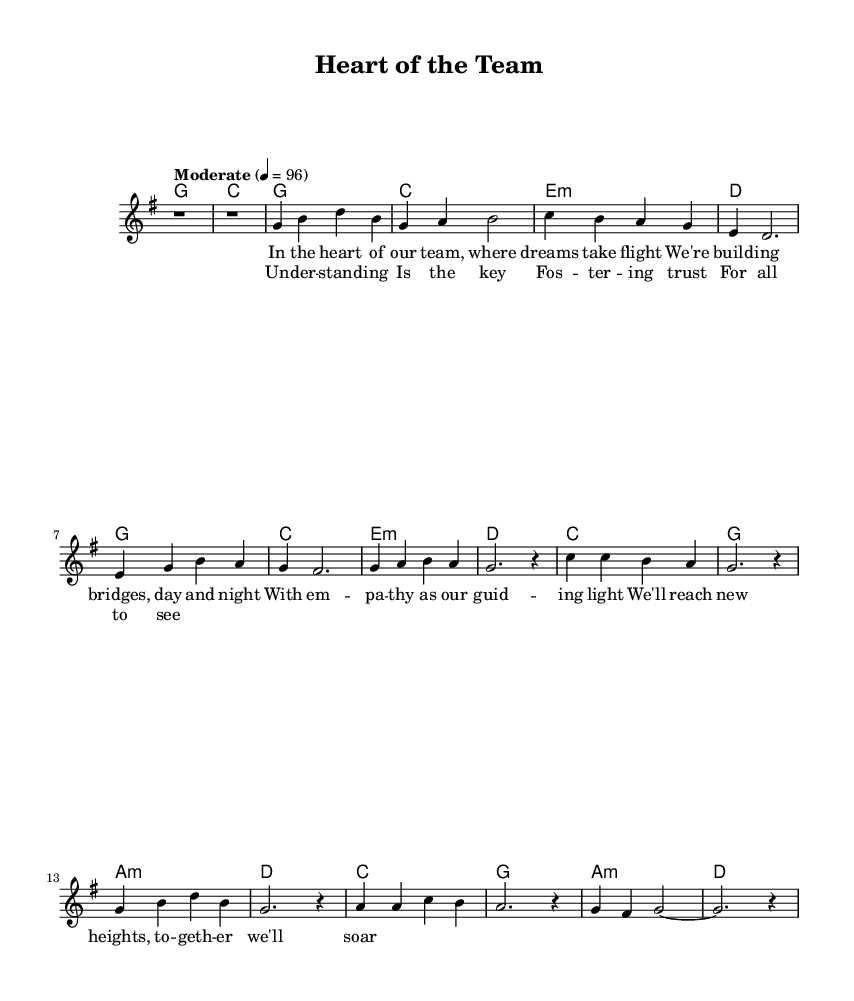What is the key signature of this music? The key signature is G major, which has one sharp (F#).
Answer: G major What is the time signature of this piece? The time signature shown in the music is 4/4, indicating four beats per measure.
Answer: 4/4 What is the tempo marking for this piece? The tempo marking provided is "Moderate," with a metronome marking of 96 beats per minute, indicating a moderate speed.
Answer: Moderate How many measures are in the verse section? Counting the measures in the verse section, there are eight measures as indicated by the corresponding notes.
Answer: 8 What is the primary lyrical theme of the chorus? The chorus lyrics emphasize understanding and fostering trust in teamwork, illustrating the emotional core of the song.
Answer: Understanding Which chord follows the D major chord in the harmony? The chord progression shows that after the D major chord, it returns to the G major chord, establishing a sense of home.
Answer: G major How does the song reflect the themes of empathy and understanding? The lyrics and overall structure emphasize collaboration and support within a team, highlighting the importance of empathy in professional relationships.
Answer: Collaboration 